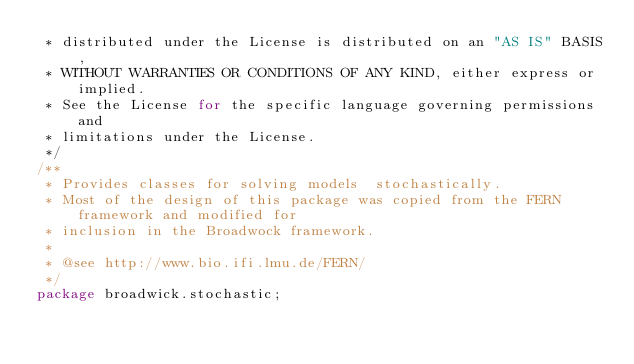Convert code to text. <code><loc_0><loc_0><loc_500><loc_500><_Java_> * distributed under the License is distributed on an "AS IS" BASIS,
 * WITHOUT WARRANTIES OR CONDITIONS OF ANY KIND, either express or implied.
 * See the License for the specific language governing permissions and
 * limitations under the License.
 */
/**
 * Provides classes for solving models  stochastically.
 * Most of the design of this package was copied from the FERN framework and modified for 
 * inclusion in the Broadwock framework.
 *
 * @see http://www.bio.ifi.lmu.de/FERN/
 */
package broadwick.stochastic;
</code> 